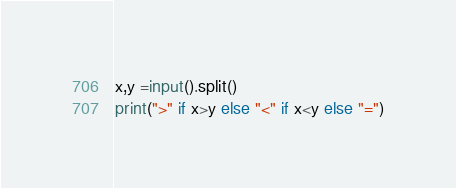Convert code to text. <code><loc_0><loc_0><loc_500><loc_500><_Python_>x,y =input().split()
print(">" if x>y else "<" if x<y else "=")</code> 